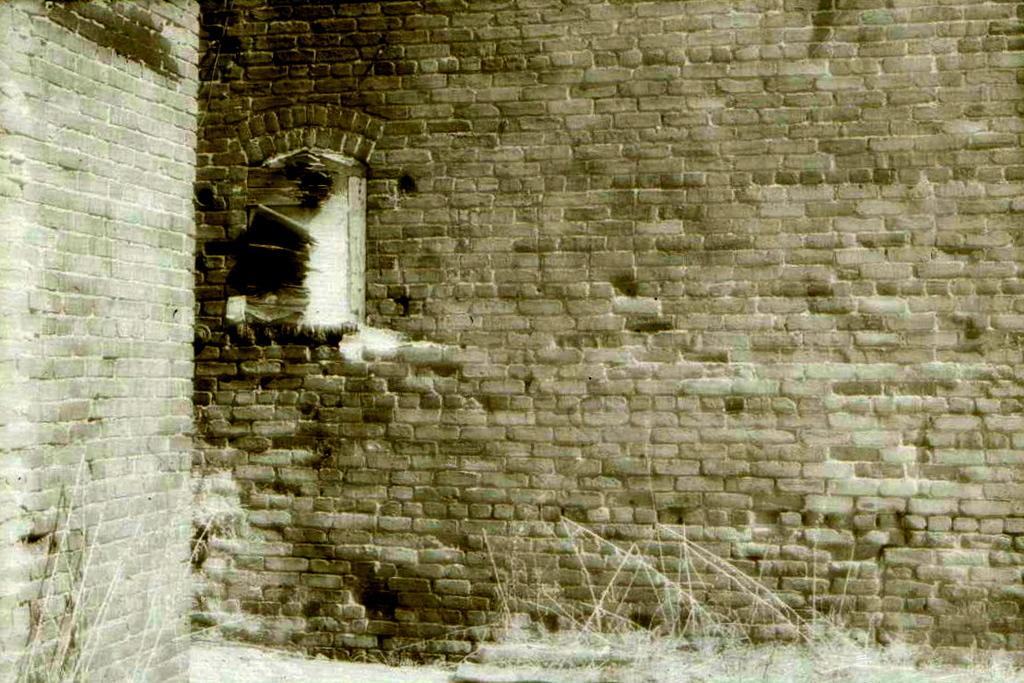What type of structure can be seen in the image? There are walls in the image, suggesting a structure of some kind. What can be seen through the window in the image? There is no reference to a window in the image, so it cannot be determined what might be visible through it. What type of natural environment is visible in the image? Grass is visible in the image, suggesting a natural environment. Where is the throne located in the image? There is no throne present in the image. Can you tell me who is getting a haircut in the image? There is no reference to a haircut or any person getting one in the image. What type of animals can be seen in the image? The provided facts do not mention any animals, so it cannot be determined what type of animals might be present in the image. 